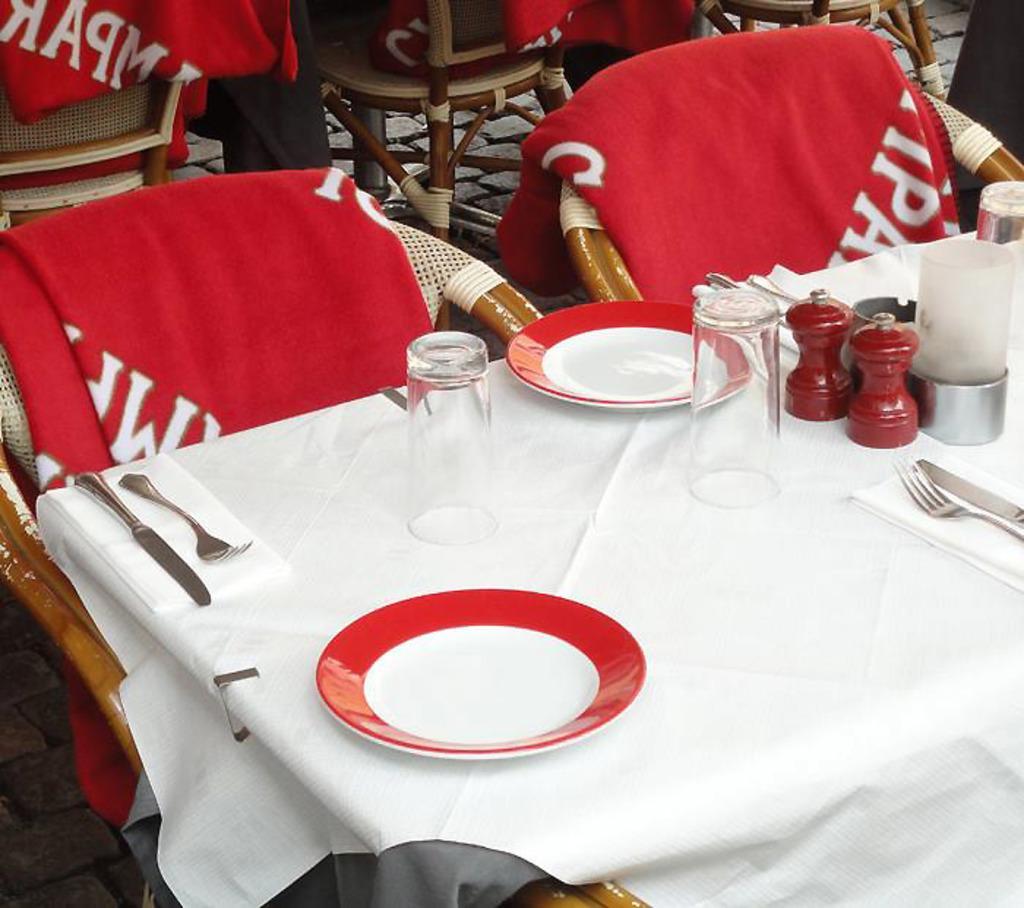Please provide a concise description of this image. This picture consists of table , on the table glasses, plates , spoons ,tissue paper, white color cloth and in front of table there are some chairs , on chairs there is a red color cloth kept on it. 